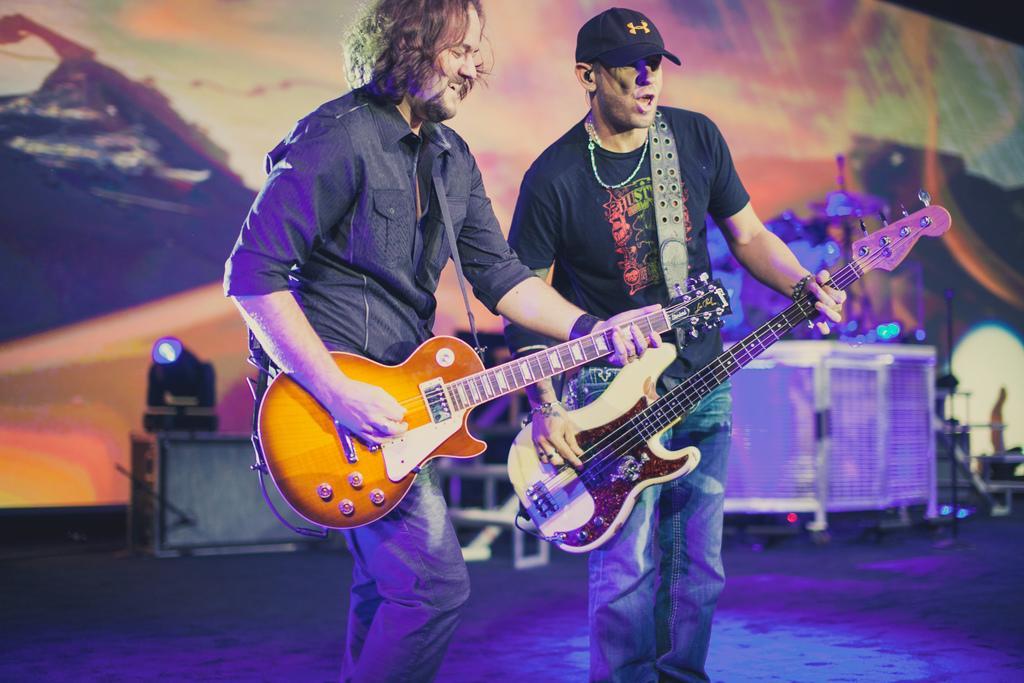Describe this image in one or two sentences. In this picture there are two men who are playing a guitar. There is a light at the background. 